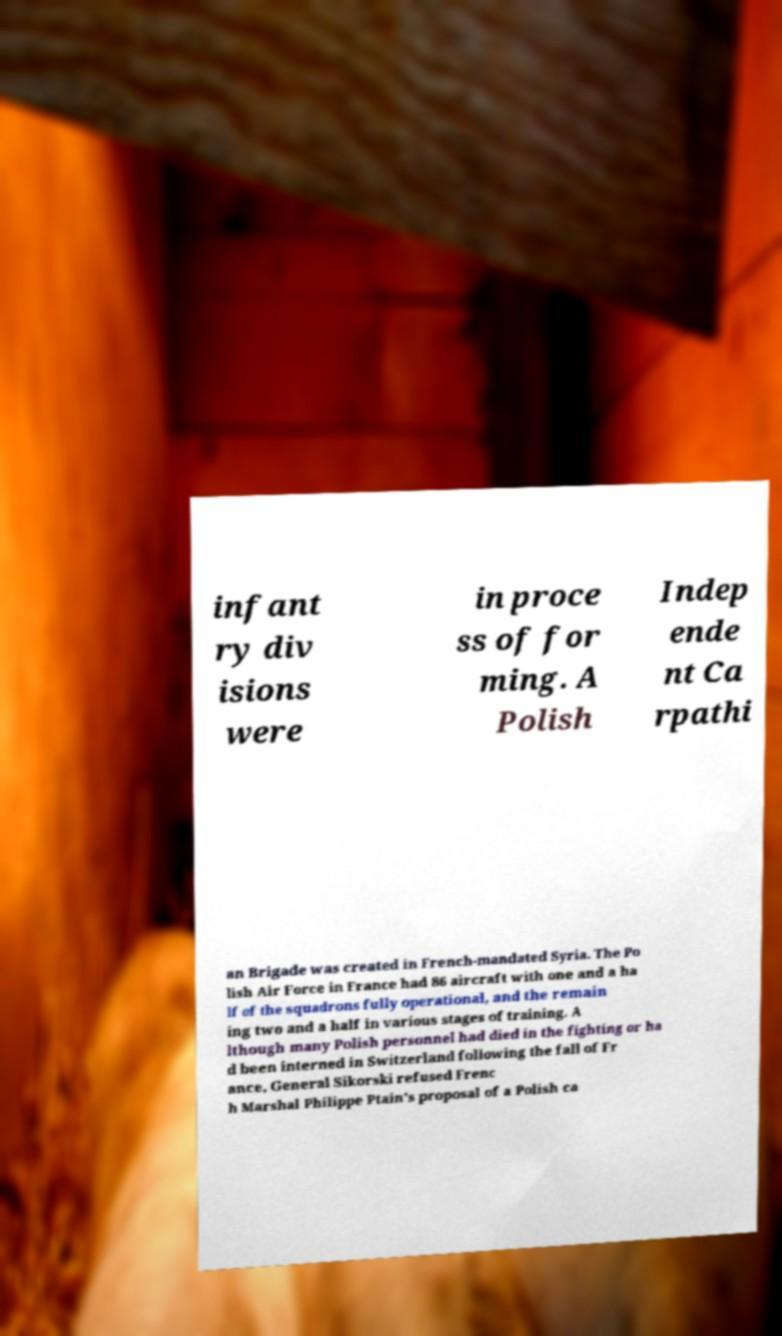There's text embedded in this image that I need extracted. Can you transcribe it verbatim? infant ry div isions were in proce ss of for ming. A Polish Indep ende nt Ca rpathi an Brigade was created in French-mandated Syria. The Po lish Air Force in France had 86 aircraft with one and a ha lf of the squadrons fully operational, and the remain ing two and a half in various stages of training. A lthough many Polish personnel had died in the fighting or ha d been interned in Switzerland following the fall of Fr ance, General Sikorski refused Frenc h Marshal Philippe Ptain's proposal of a Polish ca 